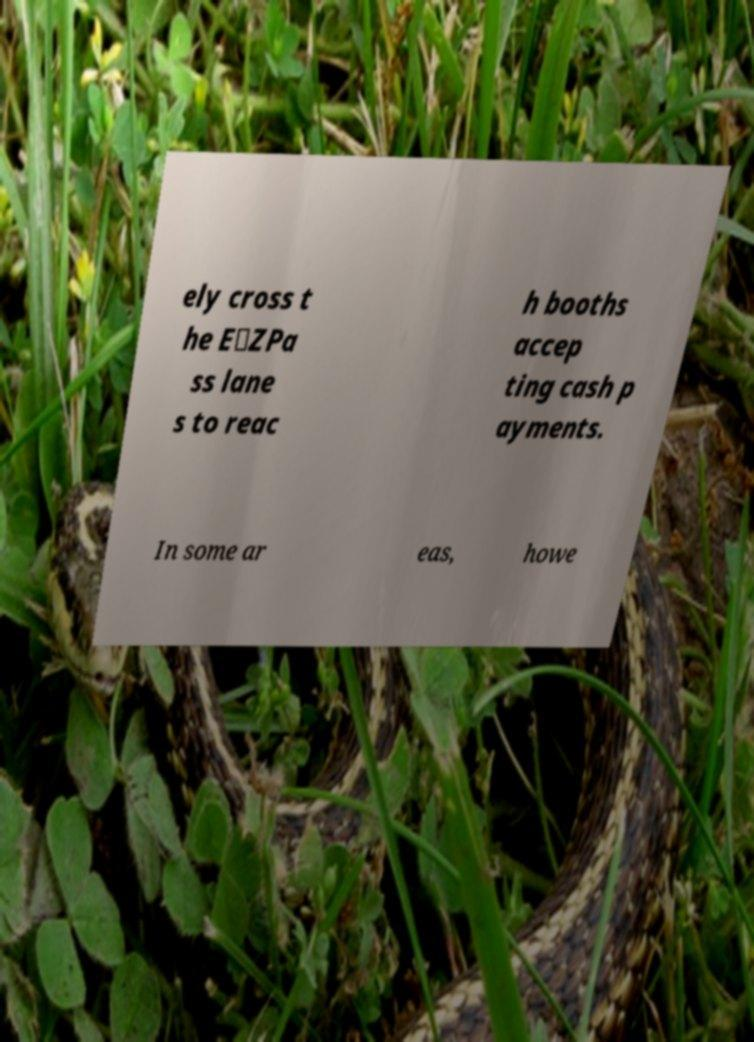What messages or text are displayed in this image? I need them in a readable, typed format. ely cross t he E‑ZPa ss lane s to reac h booths accep ting cash p ayments. In some ar eas, howe 